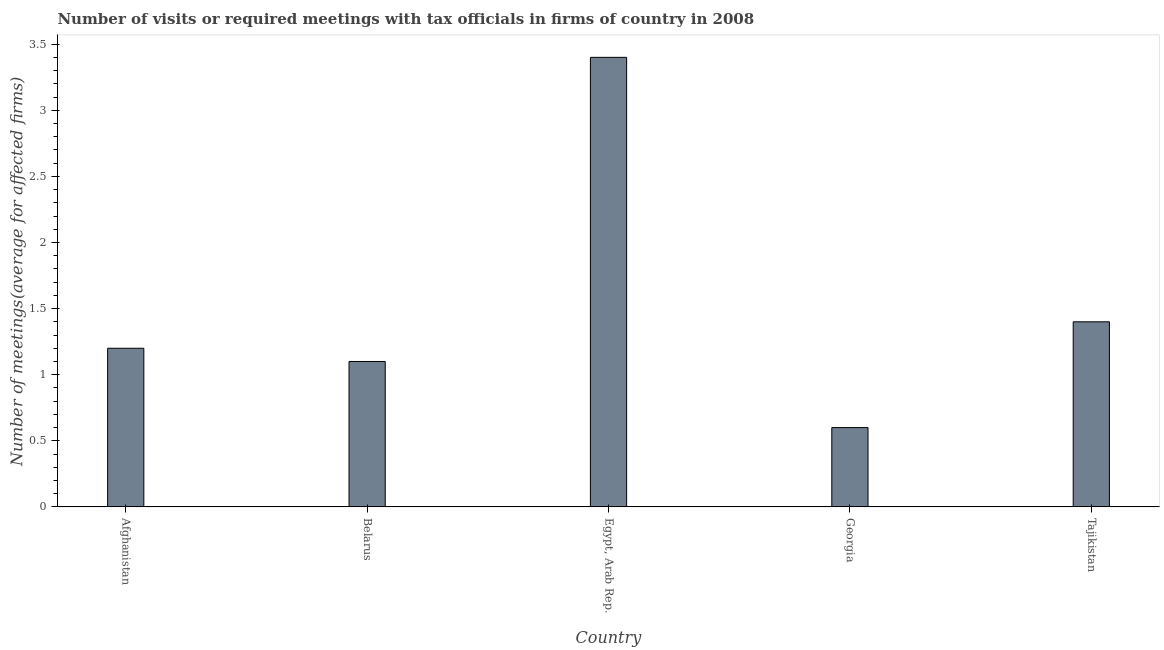Does the graph contain grids?
Ensure brevity in your answer.  No. What is the title of the graph?
Provide a short and direct response. Number of visits or required meetings with tax officials in firms of country in 2008. What is the label or title of the Y-axis?
Provide a succinct answer. Number of meetings(average for affected firms). What is the number of required meetings with tax officials in Georgia?
Offer a very short reply. 0.6. Across all countries, what is the minimum number of required meetings with tax officials?
Provide a succinct answer. 0.6. In which country was the number of required meetings with tax officials maximum?
Your answer should be compact. Egypt, Arab Rep. In which country was the number of required meetings with tax officials minimum?
Ensure brevity in your answer.  Georgia. What is the sum of the number of required meetings with tax officials?
Your answer should be very brief. 7.7. What is the average number of required meetings with tax officials per country?
Keep it short and to the point. 1.54. What is the median number of required meetings with tax officials?
Provide a short and direct response. 1.2. In how many countries, is the number of required meetings with tax officials greater than 0.8 ?
Provide a succinct answer. 4. How many bars are there?
Offer a very short reply. 5. Are all the bars in the graph horizontal?
Offer a very short reply. No. How many countries are there in the graph?
Your answer should be compact. 5. What is the difference between two consecutive major ticks on the Y-axis?
Give a very brief answer. 0.5. Are the values on the major ticks of Y-axis written in scientific E-notation?
Make the answer very short. No. What is the Number of meetings(average for affected firms) of Belarus?
Your response must be concise. 1.1. What is the Number of meetings(average for affected firms) of Egypt, Arab Rep.?
Give a very brief answer. 3.4. What is the Number of meetings(average for affected firms) in Georgia?
Ensure brevity in your answer.  0.6. What is the Number of meetings(average for affected firms) of Tajikistan?
Provide a succinct answer. 1.4. What is the difference between the Number of meetings(average for affected firms) in Afghanistan and Georgia?
Your answer should be compact. 0.6. What is the difference between the Number of meetings(average for affected firms) in Belarus and Georgia?
Give a very brief answer. 0.5. What is the difference between the Number of meetings(average for affected firms) in Belarus and Tajikistan?
Provide a short and direct response. -0.3. What is the difference between the Number of meetings(average for affected firms) in Egypt, Arab Rep. and Georgia?
Offer a terse response. 2.8. What is the difference between the Number of meetings(average for affected firms) in Georgia and Tajikistan?
Ensure brevity in your answer.  -0.8. What is the ratio of the Number of meetings(average for affected firms) in Afghanistan to that in Belarus?
Ensure brevity in your answer.  1.09. What is the ratio of the Number of meetings(average for affected firms) in Afghanistan to that in Egypt, Arab Rep.?
Offer a very short reply. 0.35. What is the ratio of the Number of meetings(average for affected firms) in Afghanistan to that in Tajikistan?
Make the answer very short. 0.86. What is the ratio of the Number of meetings(average for affected firms) in Belarus to that in Egypt, Arab Rep.?
Your response must be concise. 0.32. What is the ratio of the Number of meetings(average for affected firms) in Belarus to that in Georgia?
Your response must be concise. 1.83. What is the ratio of the Number of meetings(average for affected firms) in Belarus to that in Tajikistan?
Provide a succinct answer. 0.79. What is the ratio of the Number of meetings(average for affected firms) in Egypt, Arab Rep. to that in Georgia?
Give a very brief answer. 5.67. What is the ratio of the Number of meetings(average for affected firms) in Egypt, Arab Rep. to that in Tajikistan?
Provide a succinct answer. 2.43. What is the ratio of the Number of meetings(average for affected firms) in Georgia to that in Tajikistan?
Your answer should be very brief. 0.43. 